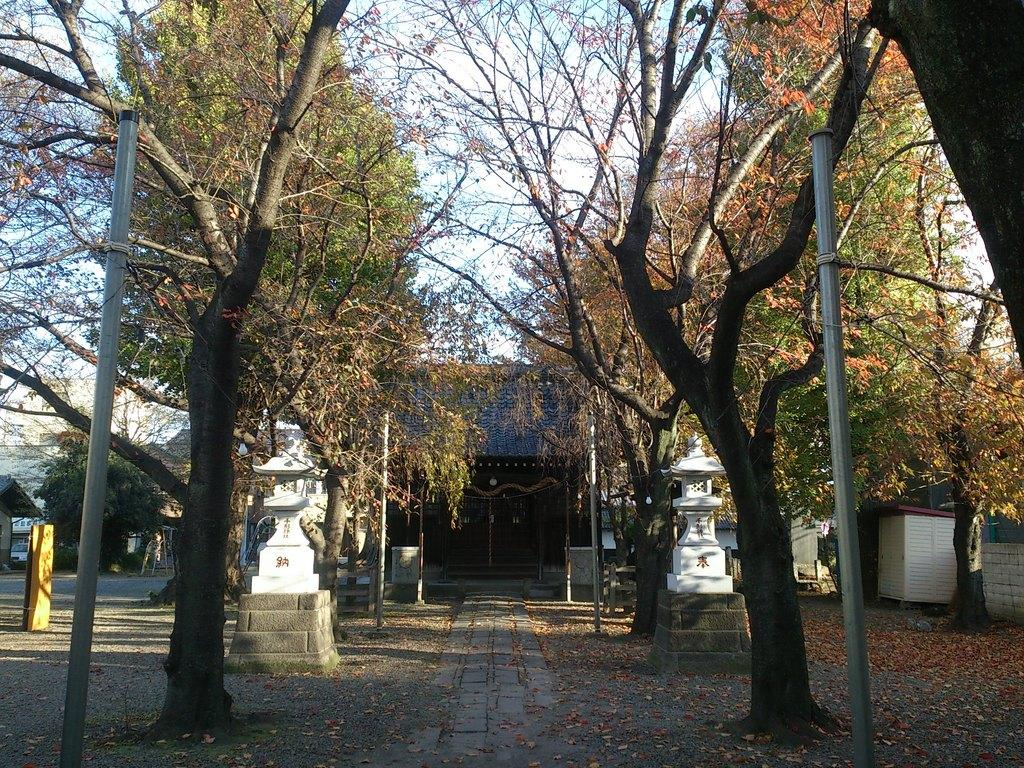What structures are present in the image? There are poles and pillars in the image. What type of vegetation can be seen on both sides of the image? There are trees on the right side and the left side of the image. What can be seen in the background of the image? There are houses in the background of the image. What type of ornament is hanging from the poles in the image? There is no ornament hanging from the poles in the image. What message of hope can be seen in the image? There is no message of hope present in the image. 